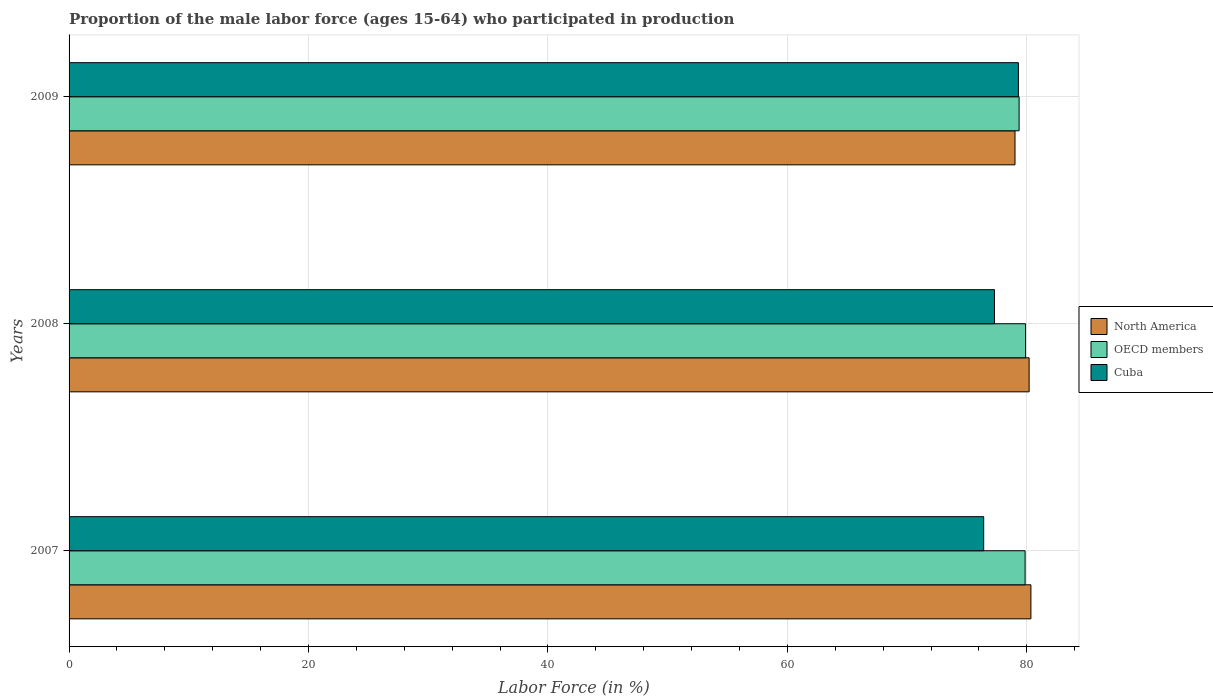How many groups of bars are there?
Make the answer very short. 3. How many bars are there on the 3rd tick from the top?
Your answer should be compact. 3. How many bars are there on the 1st tick from the bottom?
Your response must be concise. 3. What is the label of the 2nd group of bars from the top?
Your answer should be very brief. 2008. In how many cases, is the number of bars for a given year not equal to the number of legend labels?
Ensure brevity in your answer.  0. What is the proportion of the male labor force who participated in production in OECD members in 2007?
Give a very brief answer. 79.86. Across all years, what is the maximum proportion of the male labor force who participated in production in North America?
Ensure brevity in your answer.  80.34. Across all years, what is the minimum proportion of the male labor force who participated in production in North America?
Your answer should be compact. 79.02. In which year was the proportion of the male labor force who participated in production in Cuba minimum?
Provide a succinct answer. 2007. What is the total proportion of the male labor force who participated in production in OECD members in the graph?
Provide a short and direct response. 239.12. What is the difference between the proportion of the male labor force who participated in production in North America in 2007 and that in 2009?
Your response must be concise. 1.33. What is the difference between the proportion of the male labor force who participated in production in Cuba in 2009 and the proportion of the male labor force who participated in production in North America in 2008?
Ensure brevity in your answer.  -0.89. What is the average proportion of the male labor force who participated in production in North America per year?
Your answer should be compact. 79.85. In the year 2009, what is the difference between the proportion of the male labor force who participated in production in OECD members and proportion of the male labor force who participated in production in Cuba?
Give a very brief answer. 0.06. In how many years, is the proportion of the male labor force who participated in production in Cuba greater than 40 %?
Make the answer very short. 3. What is the ratio of the proportion of the male labor force who participated in production in OECD members in 2008 to that in 2009?
Your response must be concise. 1.01. Is the difference between the proportion of the male labor force who participated in production in OECD members in 2007 and 2008 greater than the difference between the proportion of the male labor force who participated in production in Cuba in 2007 and 2008?
Your answer should be very brief. Yes. What is the difference between the highest and the second highest proportion of the male labor force who participated in production in Cuba?
Provide a short and direct response. 2. What is the difference between the highest and the lowest proportion of the male labor force who participated in production in OECD members?
Offer a terse response. 0.54. Is the sum of the proportion of the male labor force who participated in production in Cuba in 2008 and 2009 greater than the maximum proportion of the male labor force who participated in production in OECD members across all years?
Offer a terse response. Yes. What does the 2nd bar from the top in 2008 represents?
Make the answer very short. OECD members. How many bars are there?
Your response must be concise. 9. Are all the bars in the graph horizontal?
Your response must be concise. Yes. How many years are there in the graph?
Give a very brief answer. 3. Does the graph contain grids?
Your answer should be compact. Yes. What is the title of the graph?
Provide a succinct answer. Proportion of the male labor force (ages 15-64) who participated in production. Does "Madagascar" appear as one of the legend labels in the graph?
Your answer should be compact. No. What is the label or title of the Y-axis?
Your answer should be compact. Years. What is the Labor Force (in %) in North America in 2007?
Give a very brief answer. 80.34. What is the Labor Force (in %) of OECD members in 2007?
Your answer should be very brief. 79.86. What is the Labor Force (in %) in Cuba in 2007?
Provide a succinct answer. 76.4. What is the Labor Force (in %) in North America in 2008?
Ensure brevity in your answer.  80.19. What is the Labor Force (in %) in OECD members in 2008?
Offer a terse response. 79.9. What is the Labor Force (in %) of Cuba in 2008?
Your answer should be very brief. 77.3. What is the Labor Force (in %) in North America in 2009?
Offer a terse response. 79.02. What is the Labor Force (in %) in OECD members in 2009?
Your answer should be compact. 79.36. What is the Labor Force (in %) in Cuba in 2009?
Offer a very short reply. 79.3. Across all years, what is the maximum Labor Force (in %) in North America?
Provide a succinct answer. 80.34. Across all years, what is the maximum Labor Force (in %) in OECD members?
Provide a short and direct response. 79.9. Across all years, what is the maximum Labor Force (in %) of Cuba?
Offer a very short reply. 79.3. Across all years, what is the minimum Labor Force (in %) in North America?
Provide a succinct answer. 79.02. Across all years, what is the minimum Labor Force (in %) in OECD members?
Offer a terse response. 79.36. Across all years, what is the minimum Labor Force (in %) of Cuba?
Your answer should be very brief. 76.4. What is the total Labor Force (in %) of North America in the graph?
Make the answer very short. 239.55. What is the total Labor Force (in %) of OECD members in the graph?
Offer a terse response. 239.12. What is the total Labor Force (in %) of Cuba in the graph?
Offer a terse response. 233. What is the difference between the Labor Force (in %) of North America in 2007 and that in 2008?
Provide a succinct answer. 0.15. What is the difference between the Labor Force (in %) of OECD members in 2007 and that in 2008?
Offer a terse response. -0.04. What is the difference between the Labor Force (in %) of Cuba in 2007 and that in 2008?
Give a very brief answer. -0.9. What is the difference between the Labor Force (in %) in North America in 2007 and that in 2009?
Ensure brevity in your answer.  1.33. What is the difference between the Labor Force (in %) in OECD members in 2007 and that in 2009?
Provide a succinct answer. 0.5. What is the difference between the Labor Force (in %) of North America in 2008 and that in 2009?
Make the answer very short. 1.18. What is the difference between the Labor Force (in %) in OECD members in 2008 and that in 2009?
Your response must be concise. 0.54. What is the difference between the Labor Force (in %) of North America in 2007 and the Labor Force (in %) of OECD members in 2008?
Give a very brief answer. 0.45. What is the difference between the Labor Force (in %) of North America in 2007 and the Labor Force (in %) of Cuba in 2008?
Your answer should be compact. 3.04. What is the difference between the Labor Force (in %) of OECD members in 2007 and the Labor Force (in %) of Cuba in 2008?
Your answer should be compact. 2.56. What is the difference between the Labor Force (in %) in North America in 2007 and the Labor Force (in %) in OECD members in 2009?
Provide a short and direct response. 0.98. What is the difference between the Labor Force (in %) in North America in 2007 and the Labor Force (in %) in Cuba in 2009?
Offer a very short reply. 1.04. What is the difference between the Labor Force (in %) in OECD members in 2007 and the Labor Force (in %) in Cuba in 2009?
Your answer should be very brief. 0.56. What is the difference between the Labor Force (in %) in North America in 2008 and the Labor Force (in %) in OECD members in 2009?
Ensure brevity in your answer.  0.84. What is the difference between the Labor Force (in %) of North America in 2008 and the Labor Force (in %) of Cuba in 2009?
Give a very brief answer. 0.89. What is the difference between the Labor Force (in %) of OECD members in 2008 and the Labor Force (in %) of Cuba in 2009?
Ensure brevity in your answer.  0.6. What is the average Labor Force (in %) in North America per year?
Provide a short and direct response. 79.85. What is the average Labor Force (in %) in OECD members per year?
Provide a succinct answer. 79.71. What is the average Labor Force (in %) in Cuba per year?
Your response must be concise. 77.67. In the year 2007, what is the difference between the Labor Force (in %) of North America and Labor Force (in %) of OECD members?
Ensure brevity in your answer.  0.48. In the year 2007, what is the difference between the Labor Force (in %) of North America and Labor Force (in %) of Cuba?
Offer a terse response. 3.94. In the year 2007, what is the difference between the Labor Force (in %) in OECD members and Labor Force (in %) in Cuba?
Provide a short and direct response. 3.46. In the year 2008, what is the difference between the Labor Force (in %) in North America and Labor Force (in %) in OECD members?
Provide a succinct answer. 0.3. In the year 2008, what is the difference between the Labor Force (in %) in North America and Labor Force (in %) in Cuba?
Offer a very short reply. 2.89. In the year 2008, what is the difference between the Labor Force (in %) in OECD members and Labor Force (in %) in Cuba?
Ensure brevity in your answer.  2.6. In the year 2009, what is the difference between the Labor Force (in %) in North America and Labor Force (in %) in OECD members?
Your answer should be very brief. -0.34. In the year 2009, what is the difference between the Labor Force (in %) of North America and Labor Force (in %) of Cuba?
Keep it short and to the point. -0.28. In the year 2009, what is the difference between the Labor Force (in %) in OECD members and Labor Force (in %) in Cuba?
Ensure brevity in your answer.  0.06. What is the ratio of the Labor Force (in %) in OECD members in 2007 to that in 2008?
Give a very brief answer. 1. What is the ratio of the Labor Force (in %) in Cuba in 2007 to that in 2008?
Give a very brief answer. 0.99. What is the ratio of the Labor Force (in %) of North America in 2007 to that in 2009?
Ensure brevity in your answer.  1.02. What is the ratio of the Labor Force (in %) in Cuba in 2007 to that in 2009?
Make the answer very short. 0.96. What is the ratio of the Labor Force (in %) of North America in 2008 to that in 2009?
Keep it short and to the point. 1.01. What is the ratio of the Labor Force (in %) of OECD members in 2008 to that in 2009?
Your response must be concise. 1.01. What is the ratio of the Labor Force (in %) of Cuba in 2008 to that in 2009?
Give a very brief answer. 0.97. What is the difference between the highest and the second highest Labor Force (in %) in North America?
Your response must be concise. 0.15. What is the difference between the highest and the second highest Labor Force (in %) in OECD members?
Give a very brief answer. 0.04. What is the difference between the highest and the second highest Labor Force (in %) of Cuba?
Give a very brief answer. 2. What is the difference between the highest and the lowest Labor Force (in %) of North America?
Keep it short and to the point. 1.33. What is the difference between the highest and the lowest Labor Force (in %) of OECD members?
Make the answer very short. 0.54. 